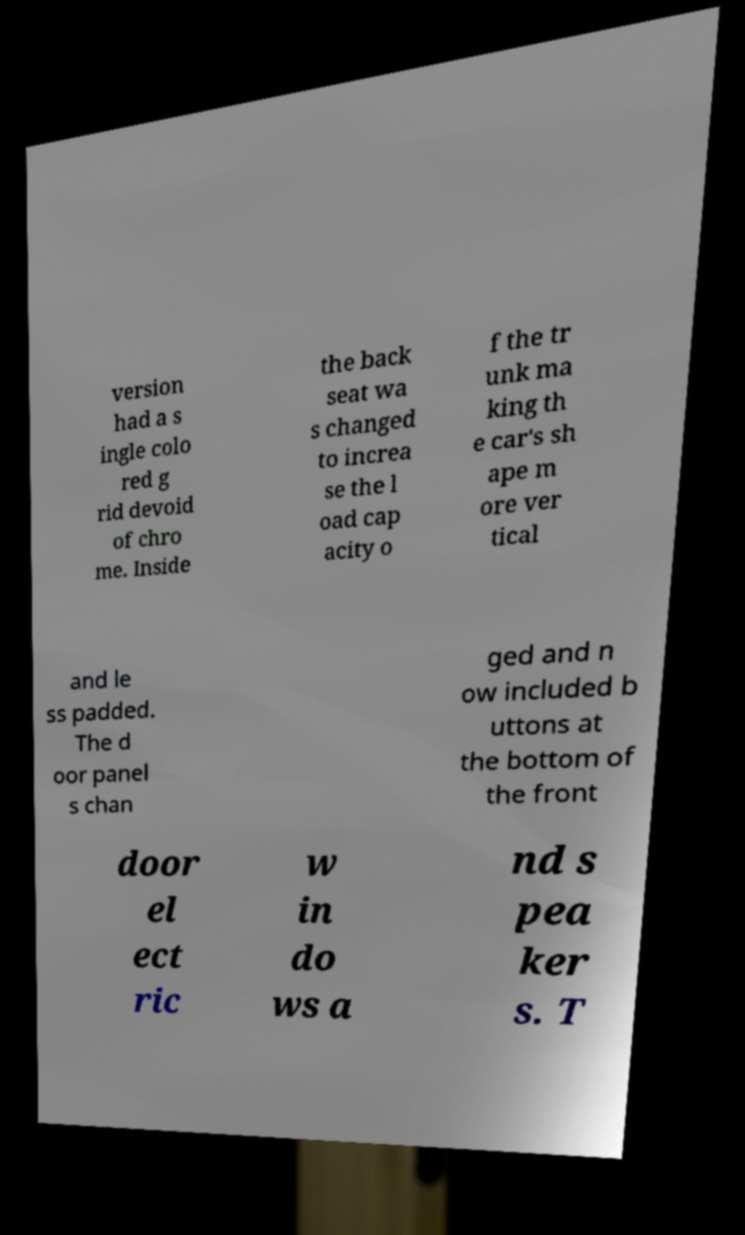I need the written content from this picture converted into text. Can you do that? version had a s ingle colo red g rid devoid of chro me. Inside the back seat wa s changed to increa se the l oad cap acity o f the tr unk ma king th e car's sh ape m ore ver tical and le ss padded. The d oor panel s chan ged and n ow included b uttons at the bottom of the front door el ect ric w in do ws a nd s pea ker s. T 